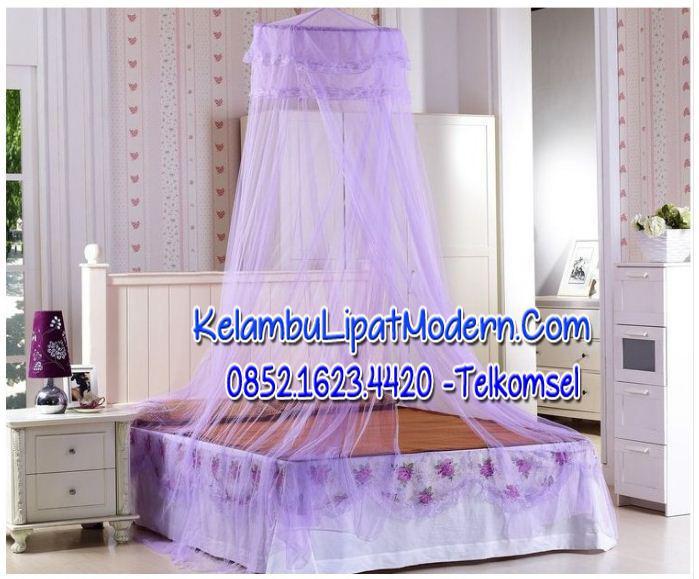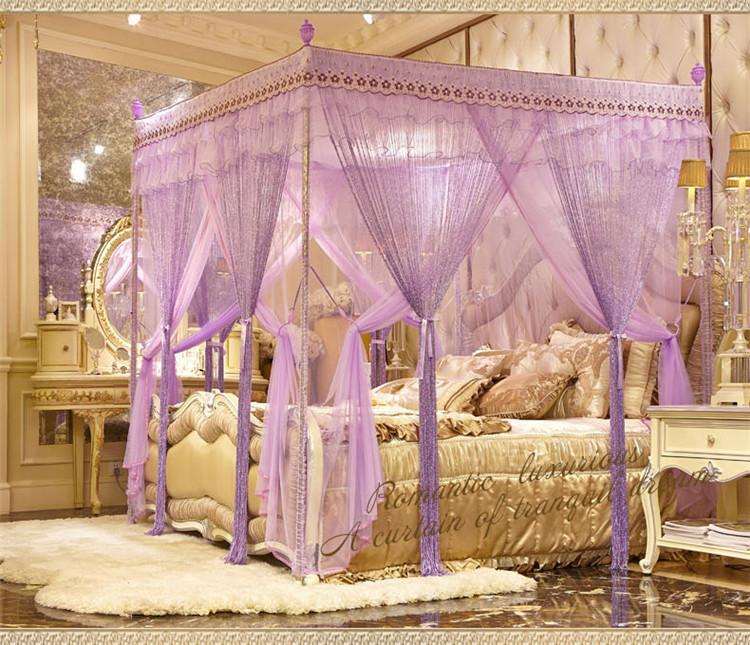The first image is the image on the left, the second image is the image on the right. Evaluate the accuracy of this statement regarding the images: "There are two purple bed canopies with headboards that are visible through them.". Is it true? Answer yes or no. Yes. The first image is the image on the left, the second image is the image on the right. For the images displayed, is the sentence "All of the bed nets are purple." factually correct? Answer yes or no. Yes. 